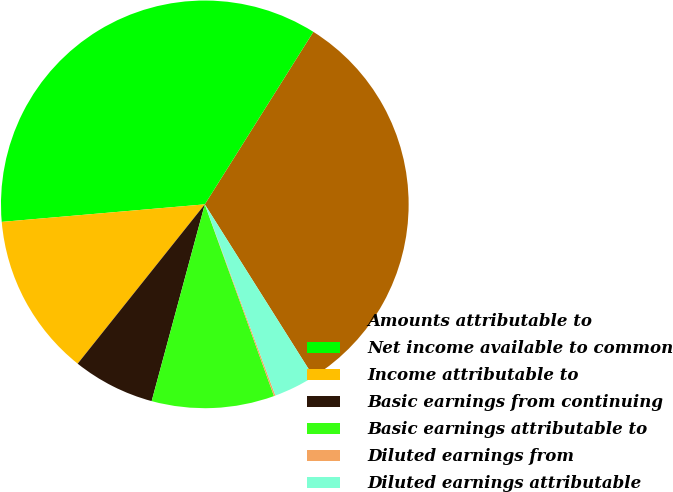<chart> <loc_0><loc_0><loc_500><loc_500><pie_chart><fcel>Amounts attributable to<fcel>Net income available to common<fcel>Income attributable to<fcel>Basic earnings from continuing<fcel>Basic earnings attributable to<fcel>Diluted earnings from<fcel>Diluted earnings attributable<nl><fcel>32.11%<fcel>35.31%<fcel>12.91%<fcel>6.52%<fcel>9.71%<fcel>0.12%<fcel>3.32%<nl></chart> 